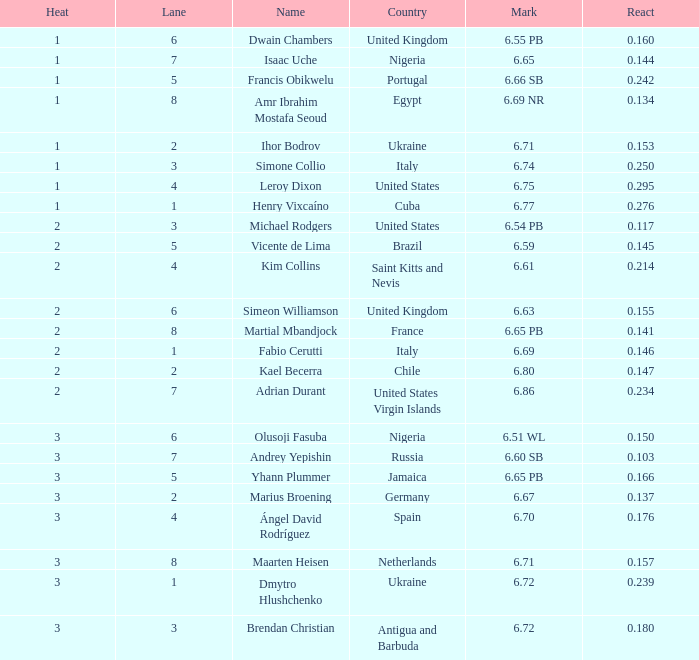What is Heat, when Mark is 6.69? 2.0. 